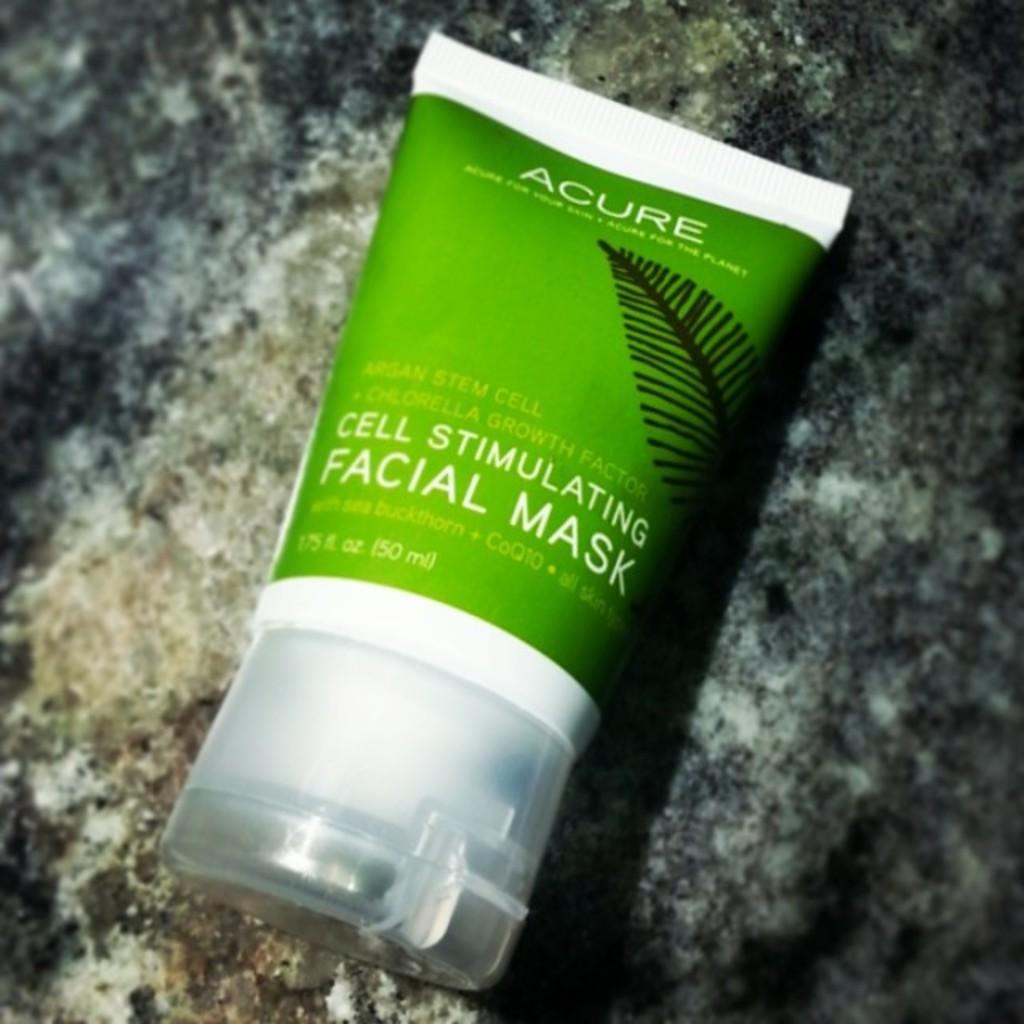What will the facial mask do to your cells?
Your response must be concise. Stimulate. 